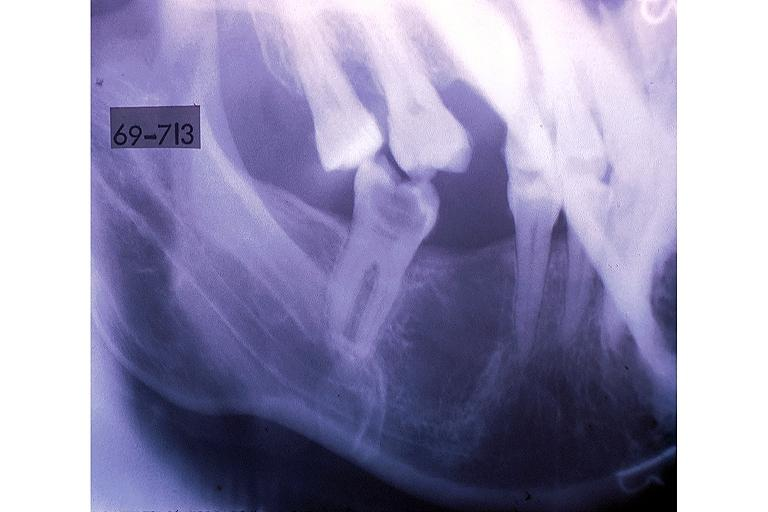where is this?
Answer the question using a single word or phrase. Oral 